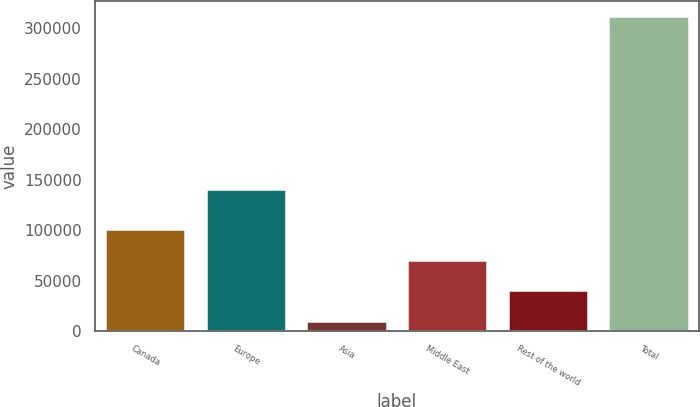<chart> <loc_0><loc_0><loc_500><loc_500><bar_chart><fcel>Canada<fcel>Europe<fcel>Asia<fcel>Middle East<fcel>Rest of the world<fcel>Total<nl><fcel>100571<fcel>140348<fcel>10180<fcel>70440.6<fcel>40310.3<fcel>311483<nl></chart> 